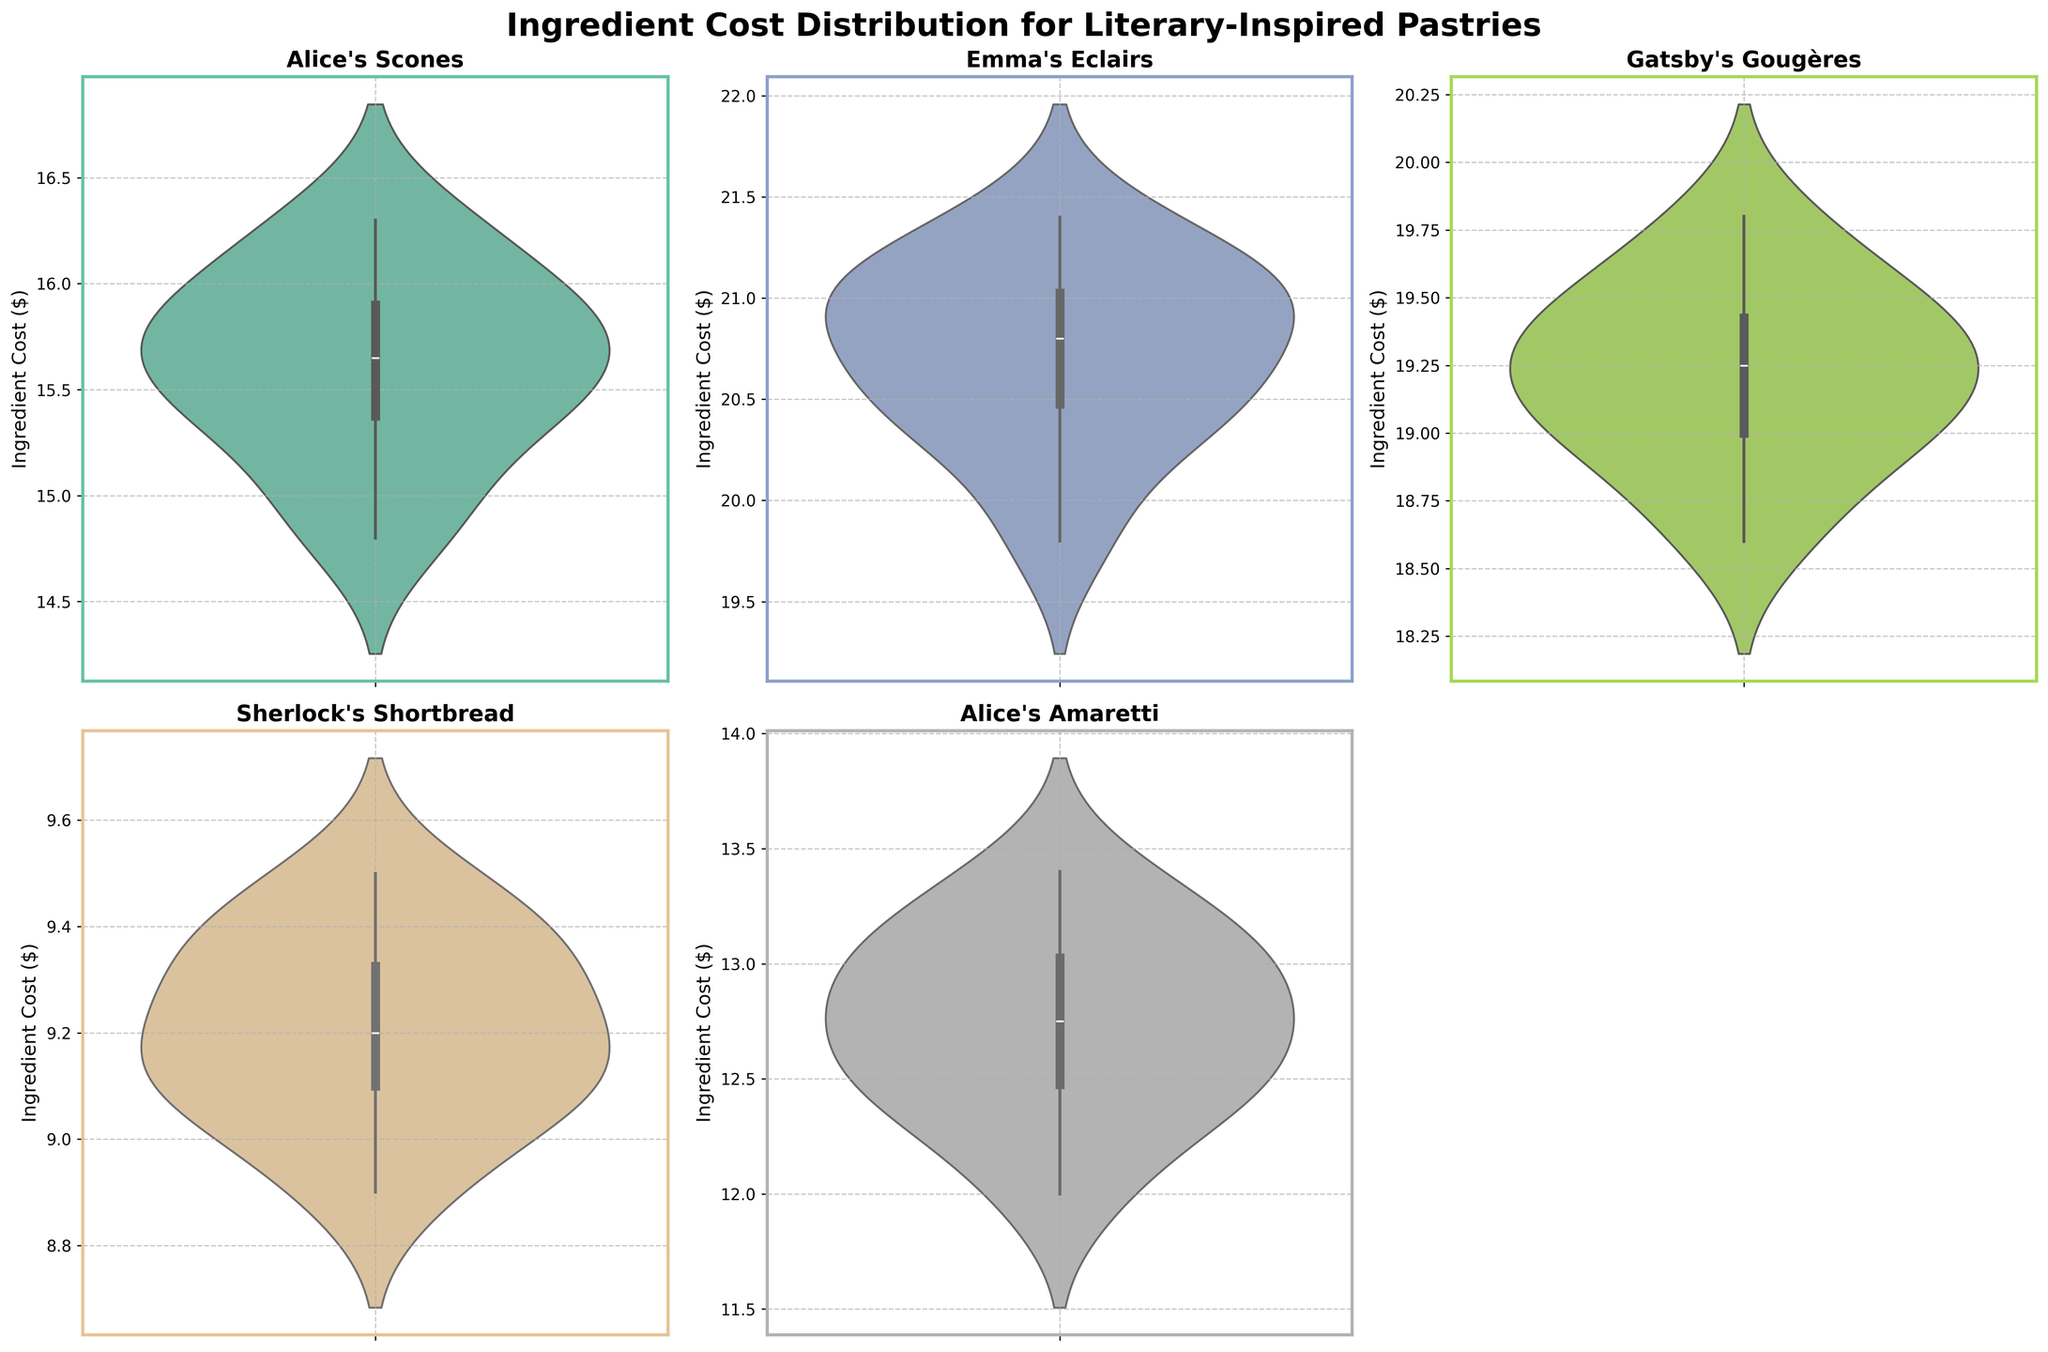Which pastry has the highest average ingredient cost? To determine the pastry with the highest average ingredient cost, look at the overall shapes of the violin plots. Emma's Eclairs show the highest ingredient cost distribution on average.
Answer: Emma's Eclairs What's the title of the chart? The title is prominently displayed above all the subplots. It reads "Ingredient Cost Distribution for Literary-Inspired Pastries."
Answer: Ingredient Cost Distribution for Literary-Inspired Pastries How does the ingredient cost variability for "Sherlock's Shortbread" compare to "Emma's Eclairs"? To compare variability, examine the width and spread of the violin plots. Sherlock's Shortbread has smaller variability, indicated by a narrower and less spread shape, compared to the broader distribution of Emma's Eclairs.
Answer: Less variable Which pastry shows the least monthly fluctuation in ingredient costs? To find the pastry with the least fluctuation, look for the narrowest violin plot. Sherlock's Shortbread has the least fluctuation in ingredient costs.
Answer: Sherlock's Shortbread Are the ingredient costs for "Alice's Scones" generally higher or lower than "Gatsby's Gougères"? By comparing the vertical position of the violin plots, Alice's Scones' distribution is generally below that of Gatsby's Gougères, indicating a lower ingredient cost.
Answer: Lower Which takes up the most space in their subplot: Alice's Amaretti or Alice's Scones? To determine which violin plot occupies more space, compare their widths and lengths. Alice's Amaretti has a more extended spread, occupying more space.
Answer: Alice's Amaretti What is the rough median ingredient cost for "Gatsby's Gougères"? The rough median is the point that divides the violin plot into two equal areas. For Gatsby's Gougères, the median is around 19.3 dollars.
Answer: 19.3 dollars Is there an obvious seasonal pattern in any of the pastry's ingredient costs? Look for consistent upward or downward trends within the violin plots. Emma's Eclairs suggest a minor seasonal increase towards the year-end.
Answer: Yes, Emma's Eclairs Does "Alice's Amaretti" have any months where the ingredient cost is particularly low compared to the rest of the year? Look for narrower sections on the violin plot that dip lower compared to other areas. Alice's Amaretti has no such significant dips, indicating relatively consistent costs across months.
Answer: No Which pastry's subplot is not included in the final figure? According to the description, the subplot for the sixth pastry, which would be the bottom right subplot, is removed. Given the listed pastries, there're only five distinct violoins included, so no subplot was excluded.
Answer: No subplot is excluded 